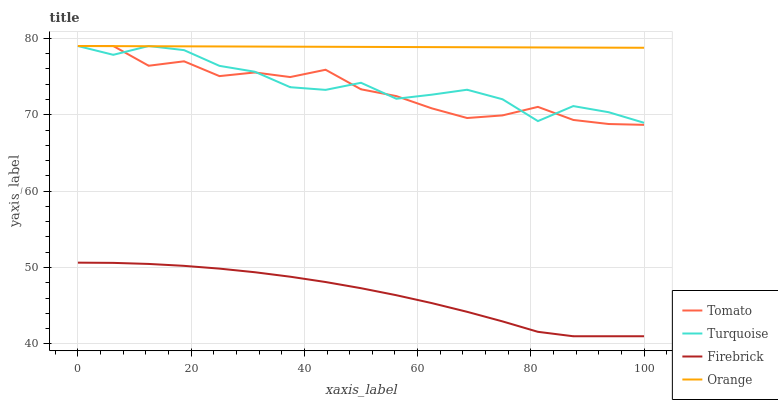Does Turquoise have the minimum area under the curve?
Answer yes or no. No. Does Turquoise have the maximum area under the curve?
Answer yes or no. No. Is Turquoise the smoothest?
Answer yes or no. No. Is Orange the roughest?
Answer yes or no. No. Does Turquoise have the lowest value?
Answer yes or no. No. Does Firebrick have the highest value?
Answer yes or no. No. Is Firebrick less than Tomato?
Answer yes or no. Yes. Is Turquoise greater than Firebrick?
Answer yes or no. Yes. Does Firebrick intersect Tomato?
Answer yes or no. No. 